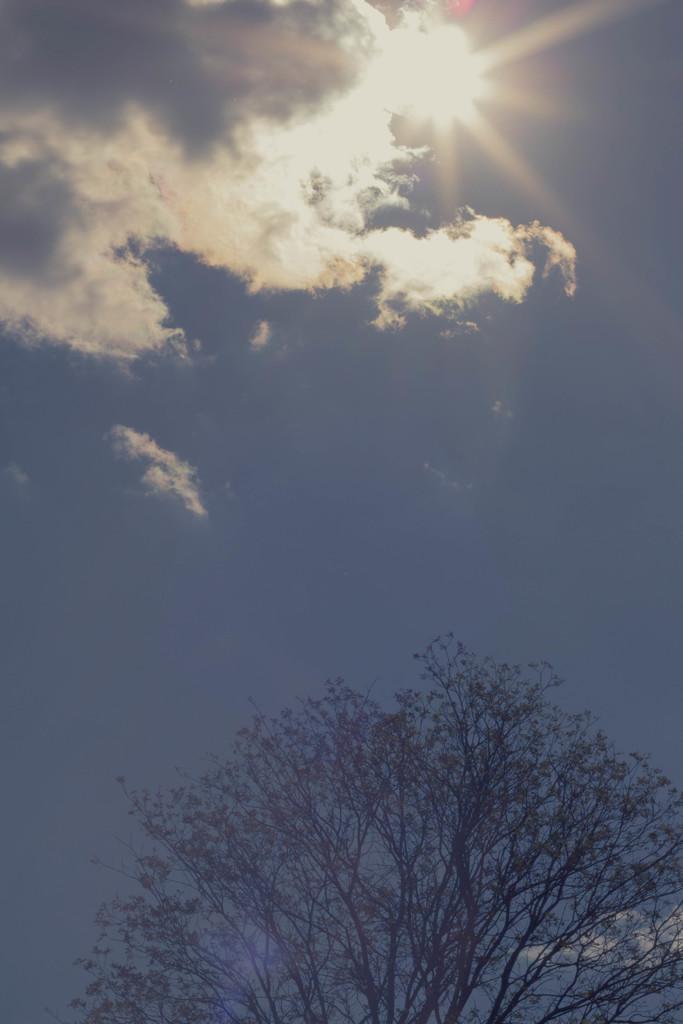In one or two sentences, can you explain what this image depicts? In this picture I can see a tree, the sky and the sun. 